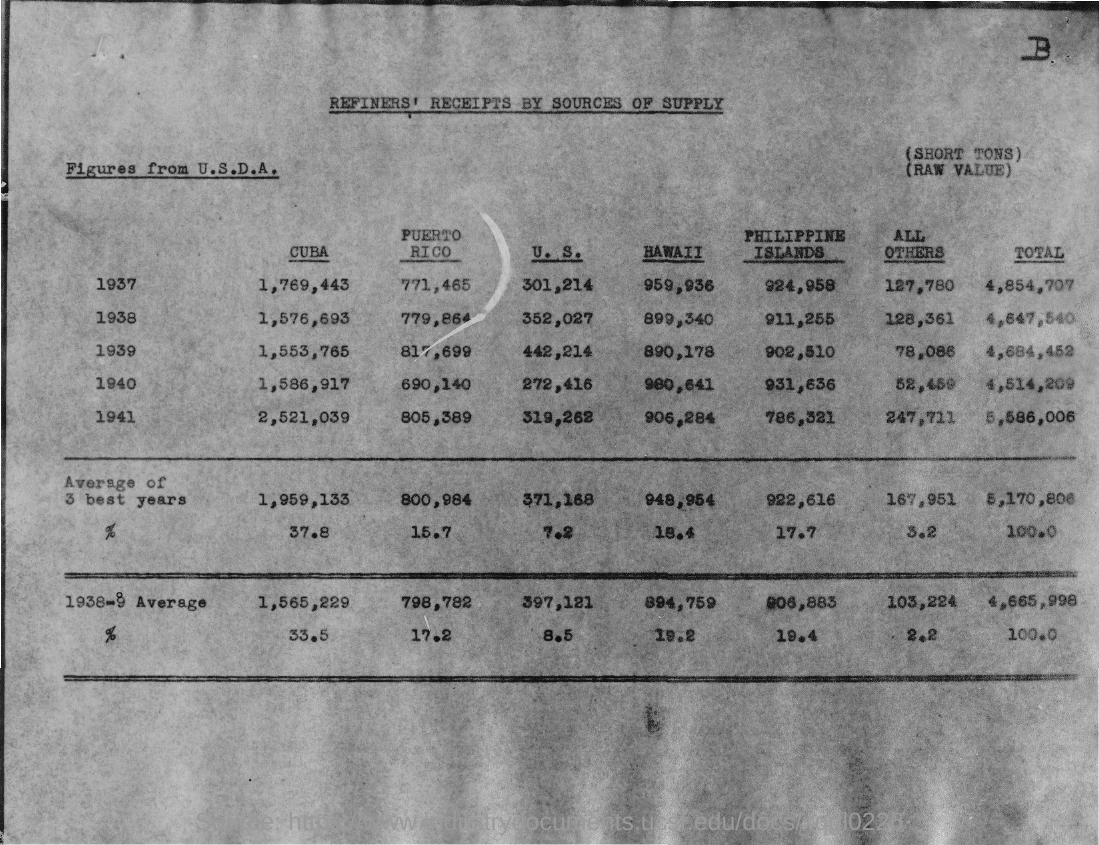What is the total in 1937?
Make the answer very short. 4,854,707. What is the total in 1938?
Provide a succinct answer. 4,647,540. What is the total in 1939?
Your answer should be very brief. 4,684,452. What is  the total in 1940?
Ensure brevity in your answer.  4,514,209. What is the total in 1941?
Your answer should be compact. 5,586,006. 